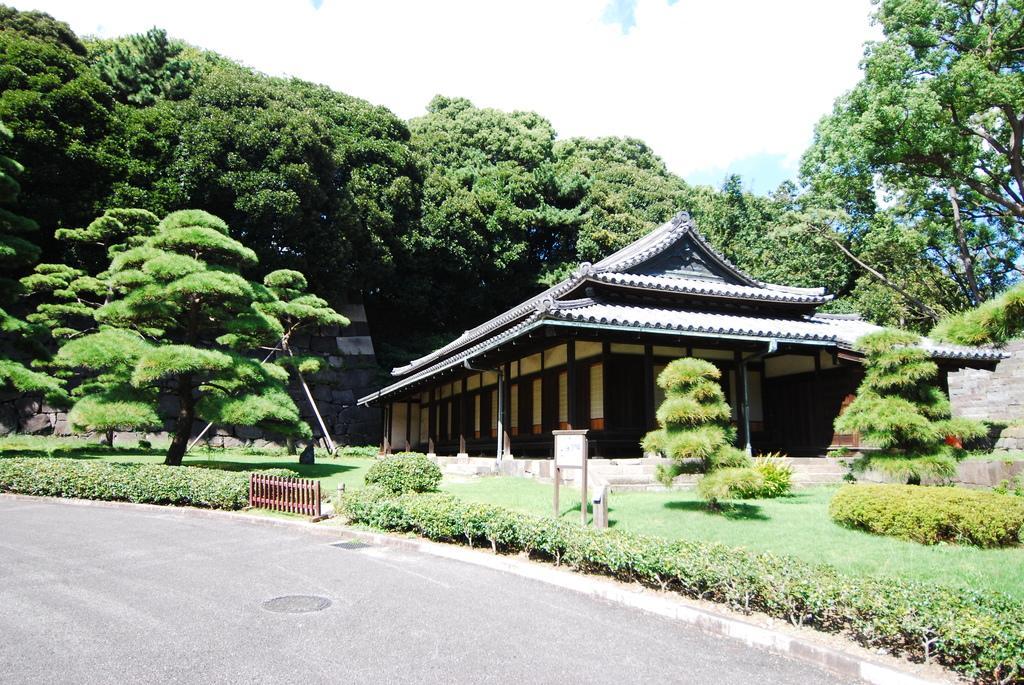Can you describe this image briefly? In this image there is a road. On the side of the road there is a small railing. Also there are plants, bushes and trees. And there is a building with pillars. In the background there are trees and there is sky with clouds. Also there is a board with poles near to the building. 